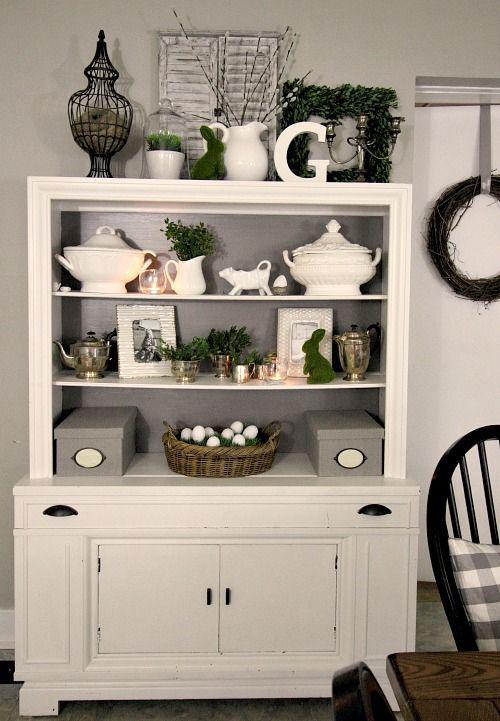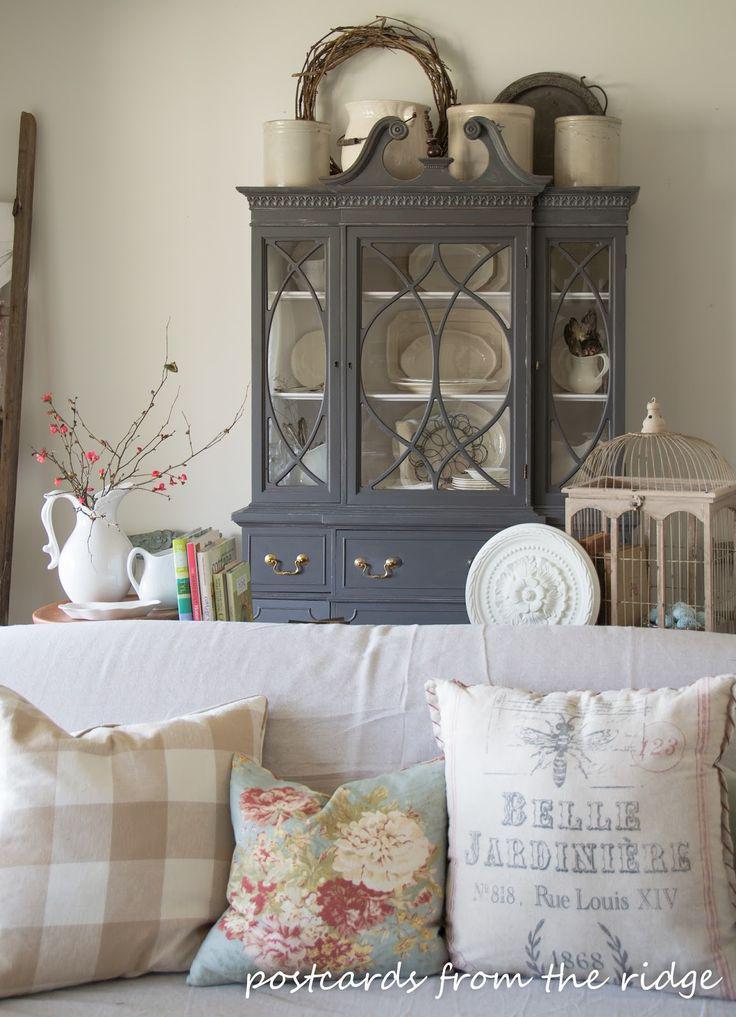The first image is the image on the left, the second image is the image on the right. Examine the images to the left and right. Is the description "The cabinet in the image on the right is charcoal grey, while the one on the left is white." accurate? Answer yes or no. Yes. The first image is the image on the left, the second image is the image on the right. Considering the images on both sides, is "One white hutch has a straight top and three shelves in the upper section, and a gray hutch has an upper center glass door that is wider than the two side glass sections." valid? Answer yes or no. Yes. 